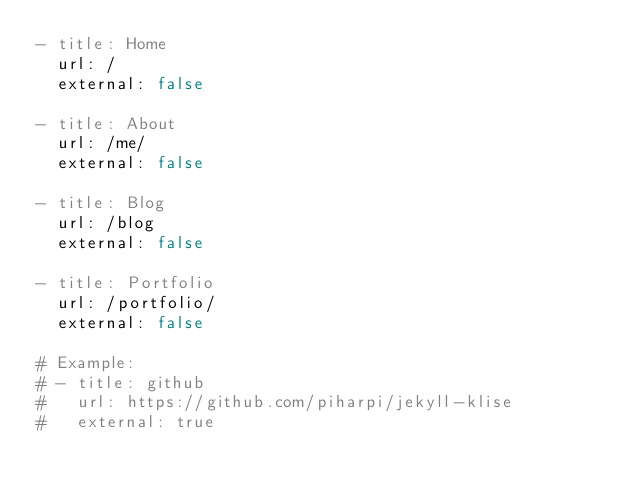<code> <loc_0><loc_0><loc_500><loc_500><_YAML_>- title: Home
  url: /
  external: false

- title: About
  url: /me/
  external: false

- title: Blog
  url: /blog
  external: false

- title: Portfolio
  url: /portfolio/
  external: false 

# Example:
# - title: github
#   url: https://github.com/piharpi/jekyll-klise
#   external: true
</code> 